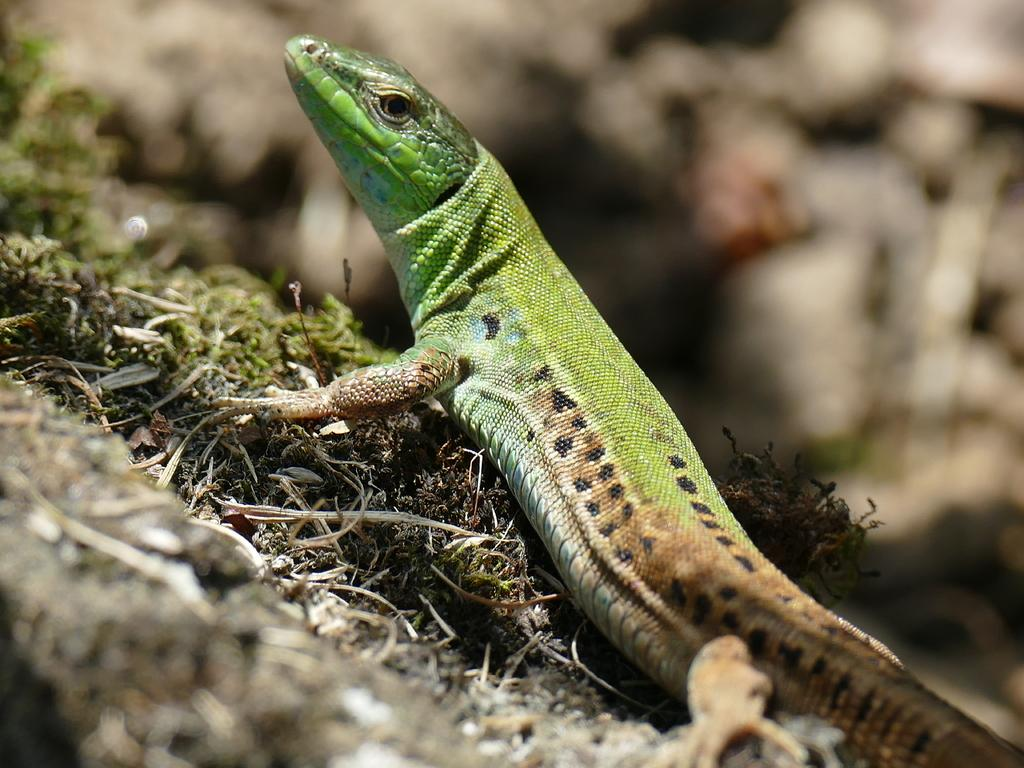What type of animal is in the image? There is a lizard in the image. Can you describe the colors of the lizard? The lizard has green and brown colors. How would you describe the background of the image? The background of the image is blurry. What type of music can be heard playing in the background of the image? There is no music present in the image; it is a photograph of a lizard with a blurry background. 